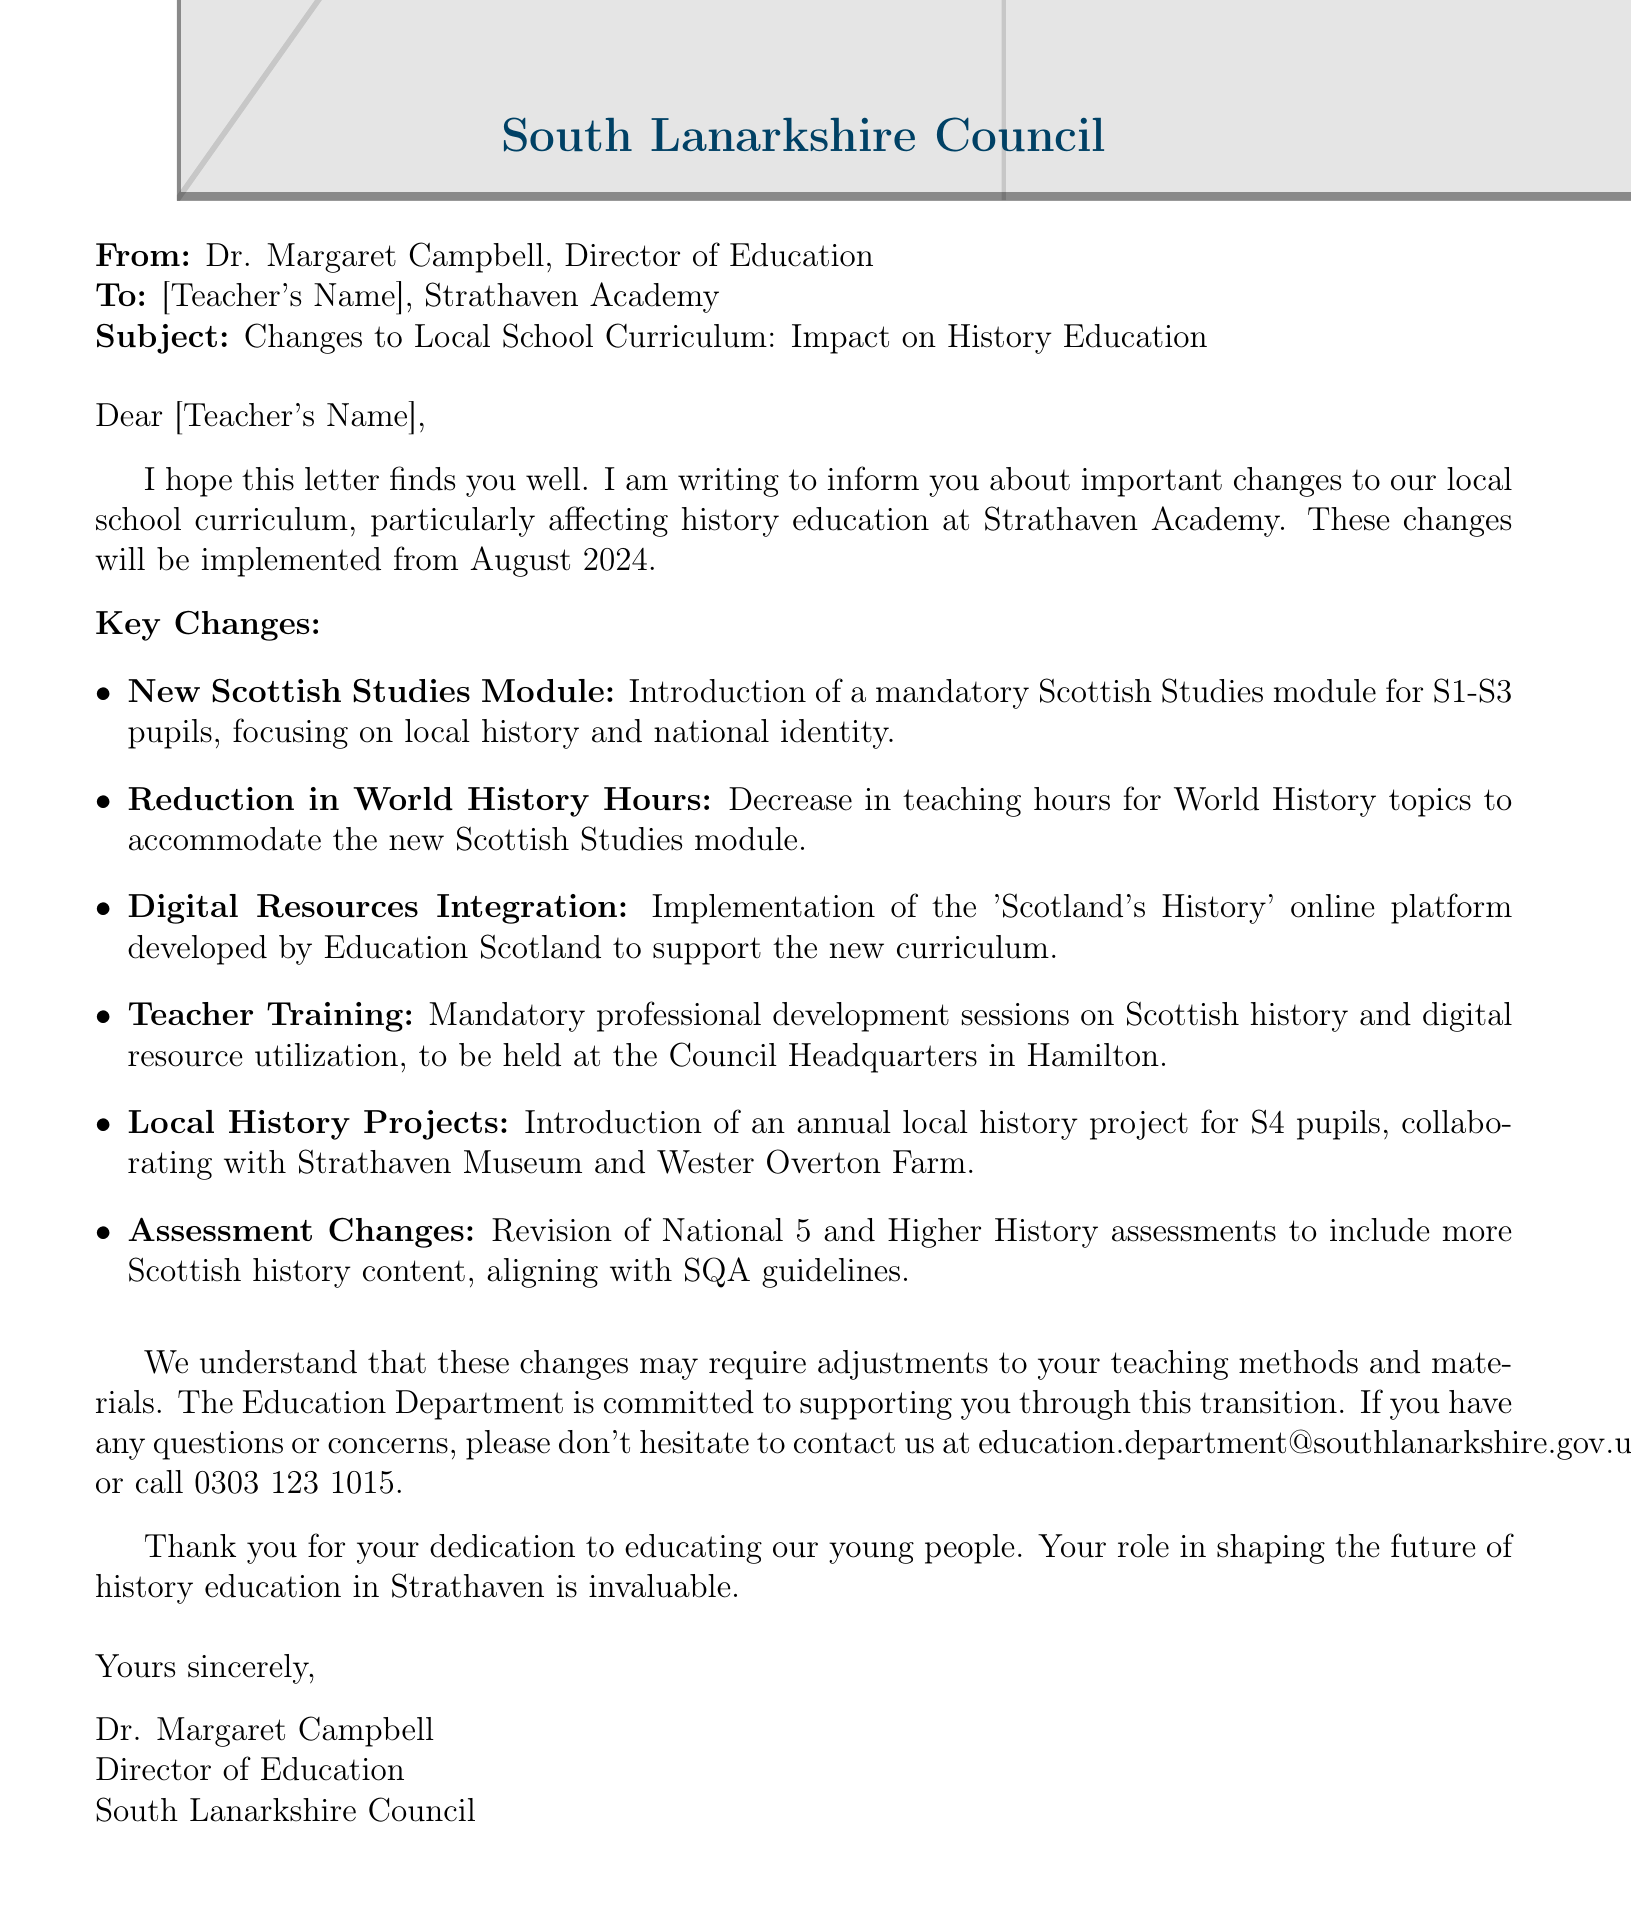What is the sender's name? The sender's name is Dr. Margaret Campbell, as stated in the document.
Answer: Dr. Margaret Campbell What is the implementation date for the changes? The document specifies that the changes will be implemented from August 2024.
Answer: August 2024 What is the focus of the new Scottish Studies module? The focus is on local history and national identity, which is mentioned in the key points.
Answer: local history and national identity How many teaching hours for World History will be reduced? The document states there will be a decrease, but does not specify a number of hours.
Answer: Decrease (number not specified) What type of projects will be introduced for S4 pupils? The document mentions an annual local history project collaborating with local institutions.
Answer: local history project What mandatory training will teachers attend? Teachers will have mandatory professional development sessions on Scottish history and digital resource utilization.
Answer: professional development sessions Which online platform will support the new curriculum? The platform mentioned is 'Scotland's History,' developed by Education Scotland.
Answer: Scotland's History Where will the teacher training sessions be held? The location for the training sessions is specified as the Council Headquarters in Hamilton.
Answer: Council Headquarters in Hamilton What assessment changes are being made? Revisions to National 5 and Higher History assessments will include more Scottish history content.
Answer: more Scottish history content 